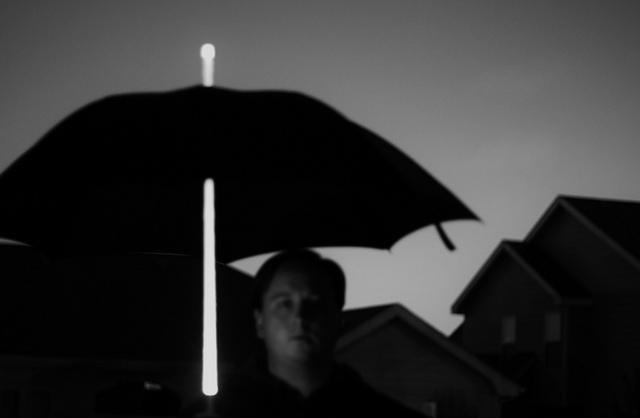How many umbrellas are there?
Give a very brief answer. 1. How many cows are in the picture?
Give a very brief answer. 0. 